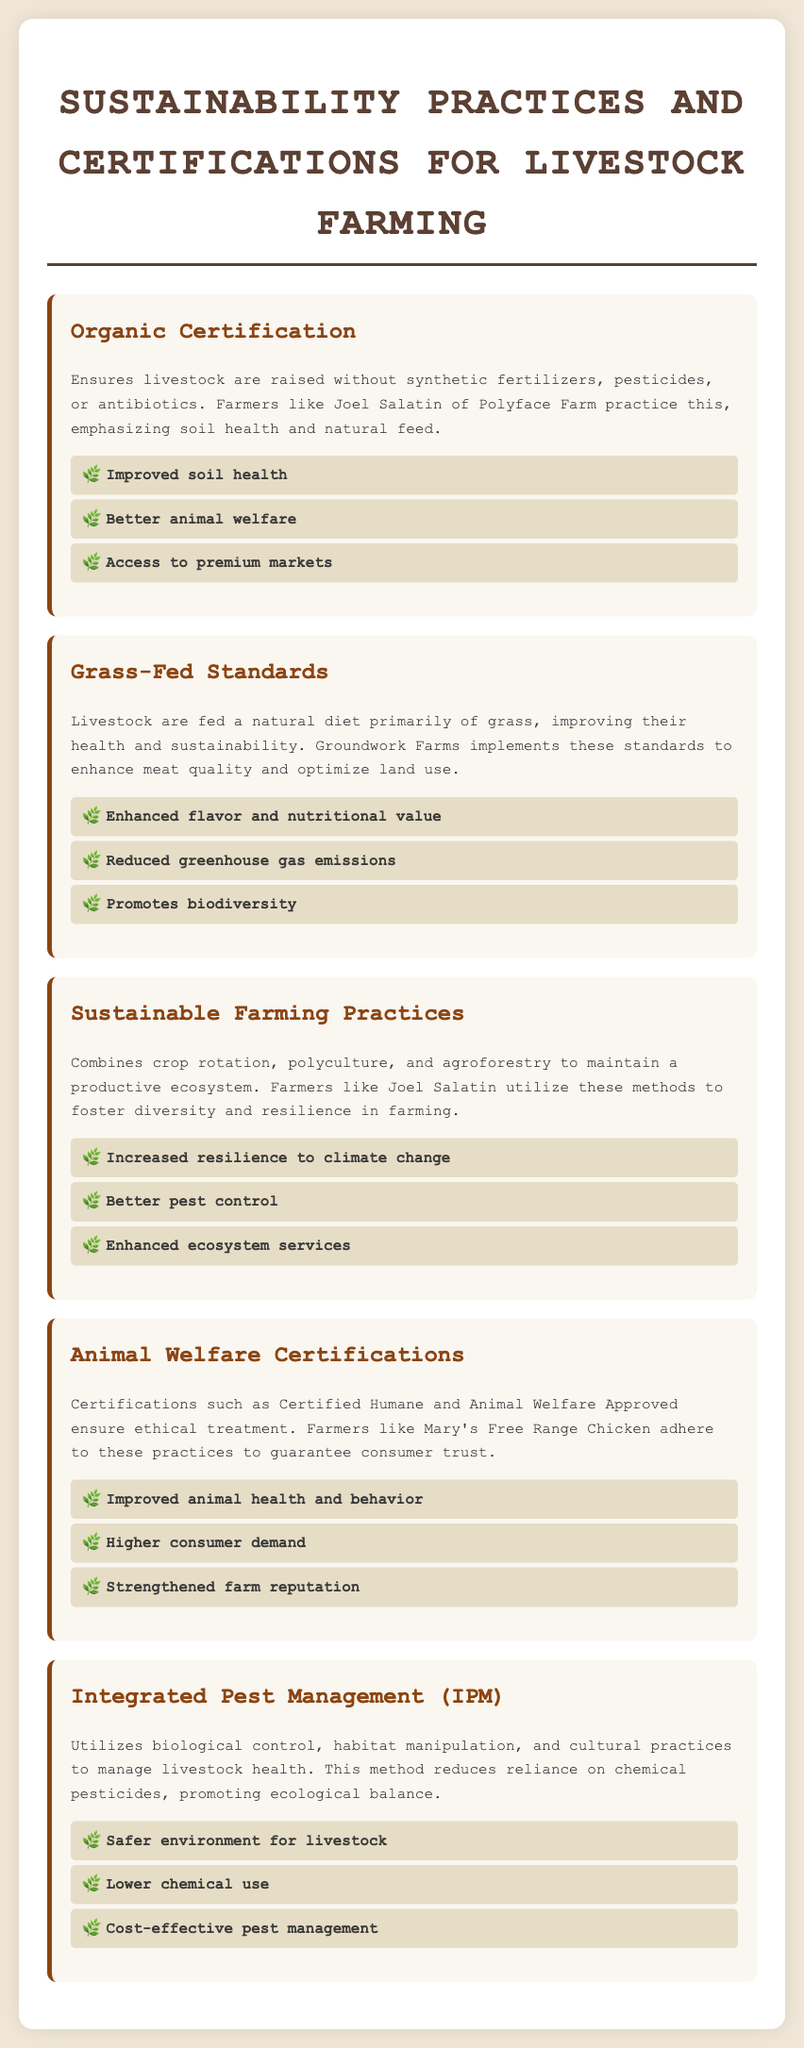What is the first sustainability practice listed? The document lists "Organic Certification" as the first sustainability practice.
Answer: Organic Certification Who is a well-known farmer practicing organic certification? The document mentions Joel Salatin as a prominent farmer practicing organic certification.
Answer: Joel Salatin What is a benefit of grass-fed standards? Among the benefits listed, "Enhanced flavor and nutritional value" is specifically noted for grass-fed standards.
Answer: Enhanced flavor and nutritional value What certification ensures ethical treatment of animals? The document lists "Certified Humane" and "Animal Welfare Approved" as certifications for ethical treatment.
Answer: Certified Humane Which farming practice is aimed at improving resilience to climate change? "Sustainable Farming Practices" is mentioned as a method that increases resilience to climate change.
Answer: Sustainable Farming Practices What does Integrated Pest Management (IPM) reduce the reliance on? The method focuses on reducing reliance on chemical pesticides, as stated in the document.
Answer: Chemical pesticides What is a benefit associated with animal welfare certifications? The document mentions "Improved animal health and behavior" as a benefit of animal welfare certifications.
Answer: Improved animal health and behavior What farming method combines crop rotation and polyculture? "Sustainable Farming Practices" is the method that combines these practices.
Answer: Sustainable Farming Practices Who implements grass-fed standards to enhance meat quality? Groundwork Farms is mentioned as implementing grass-fed standards for better meat quality.
Answer: Groundwork Farms 